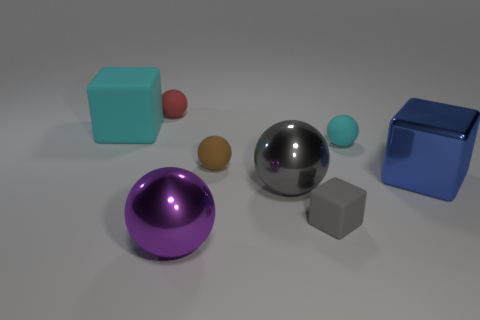Is the size of the cyan ball the same as the gray matte block?
Your answer should be very brief. Yes. What number of things are either purple metal cylinders or gray blocks?
Keep it short and to the point. 1. There is a cube that is both right of the small brown thing and to the left of the blue shiny thing; what is its size?
Give a very brief answer. Small. Is the number of big gray shiny balls behind the gray metal ball less than the number of tiny cyan matte objects?
Provide a short and direct response. Yes. There is a tiny brown thing that is made of the same material as the small red ball; what shape is it?
Give a very brief answer. Sphere. Does the small object in front of the big blue thing have the same shape as the big thing behind the blue metal block?
Ensure brevity in your answer.  Yes. Are there fewer small red spheres to the right of the gray matte thing than large metal objects that are on the left side of the big gray ball?
Your answer should be very brief. Yes. What shape is the shiny object that is the same color as the tiny cube?
Provide a succinct answer. Sphere. What number of balls have the same size as the purple metal object?
Ensure brevity in your answer.  1. Are the large block that is in front of the big cyan rubber thing and the red sphere made of the same material?
Offer a very short reply. No. 